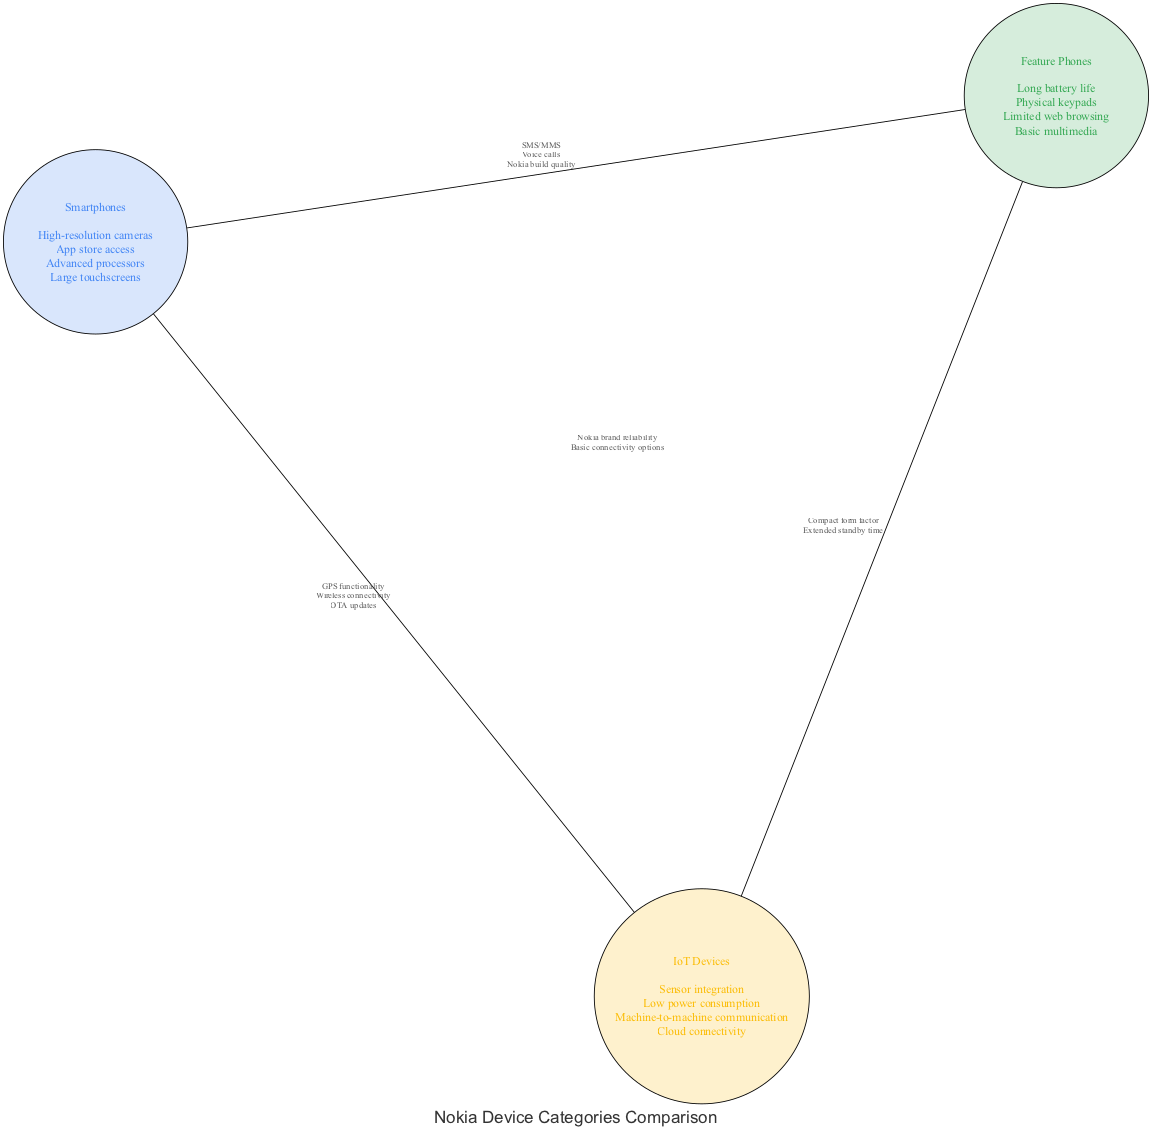What unique feature is only found in smartphones? According to the Venn diagram, the unique feature of smartphones listed is "High-resolution cameras." This element is only present in the section dedicated to smartphones, indicating it is not shared with feature phones or IoT devices.
Answer: High-resolution cameras Which two device categories share the element "SMS/MMS"? The element "SMS/MMS" is in the intersection between smartphones and feature phones. Therefore, both of these categories share this capability, as indicated by the diagram's intersection details.
Answer: Smartphones, Feature Phones How many elements are listed under the feature phones category? Upon examining the feature phones node, it contains four distinct elements: long battery life, physical keypads, limited web browsing, and basic multimedia. Counting these elements yields a total of four.
Answer: 4 What do smartphones and IoT devices both have in common? The common elements between smartphones and IoT devices include "GPS functionality," "Wireless connectivity," and "OTA updates." These capabilities demonstrate a crossover of technologies utilized in both categories, indicating they share advanced connectivity features.
Answer: GPS functionality, Wireless connectivity, OTA updates Which feature is shared among all three categories? The diagram shows that "Nokia brand reliability" and "Basic connectivity options" are common across smartphones, feature phones, and IoT devices. This indicates these attributes are foundational values present in all device types from Nokia.
Answer: Nokia brand reliability, Basic connectivity options What is a key advantage of feature phones in terms of power? The element "Long battery life," found exclusively in the feature phones category, suggests a significant advantage of feature phones regarding power efficiency. This feature is not typically emphasized in smartphones or IoT devices.
Answer: Long battery life Which two features are shared by feature phones and IoT devices? The features "Compact form factor" and "Extended standby time" are listed in the intersection of feature phones and IoT devices, showcasing that both categories possess physical and operational characteristics that lead to compactness and longevity without frequent charging.
Answer: Compact form factor, Extended standby time How many nodes are present in the diagram? The diagram includes three main nodes representing the categories: smartphones, feature phones, and IoT devices, along with intersections among them. Counting all distinct nodes gives a total of five, as the three main categories plus an additional node for each intersection is factored in.
Answer: 5 